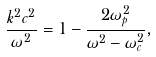<formula> <loc_0><loc_0><loc_500><loc_500>\frac { k ^ { 2 } c ^ { 2 } } { \omega ^ { 2 } } = 1 - \frac { 2 \omega _ { p } ^ { 2 } } { \omega ^ { 2 } - \omega _ { c } ^ { 2 } } ,</formula> 